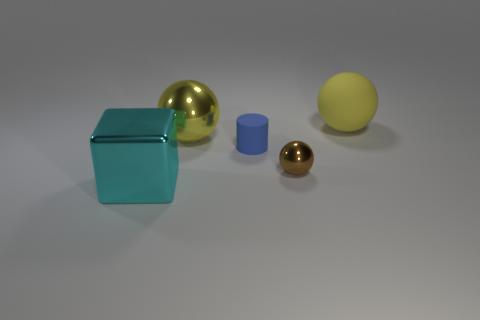Add 4 brown things. How many objects exist? 9 Subtract all cubes. How many objects are left? 4 Add 1 brown metallic balls. How many brown metallic balls exist? 2 Subtract 0 red cubes. How many objects are left? 5 Subtract all tiny red objects. Subtract all blue matte things. How many objects are left? 4 Add 5 small metallic things. How many small metallic things are left? 6 